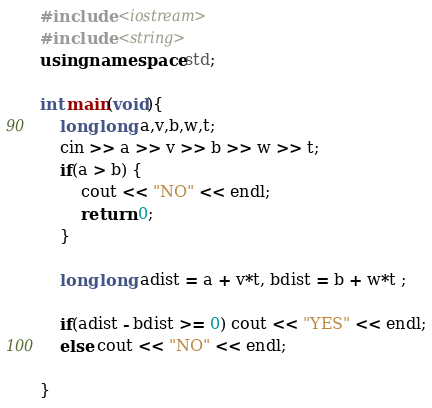<code> <loc_0><loc_0><loc_500><loc_500><_C++_>#include <iostream>
#include <string>
using namespace std;

int main(void){
    long long a,v,b,w,t;
    cin >> a >> v >> b >> w >> t;
    if(a > b) {
        cout << "NO" << endl;
        return 0;
    }
    
    long long adist = a + v*t, bdist = b + w*t ;
    
    if(adist - bdist >= 0) cout << "YES" << endl;
    else cout << "NO" << endl;
    
}
</code> 